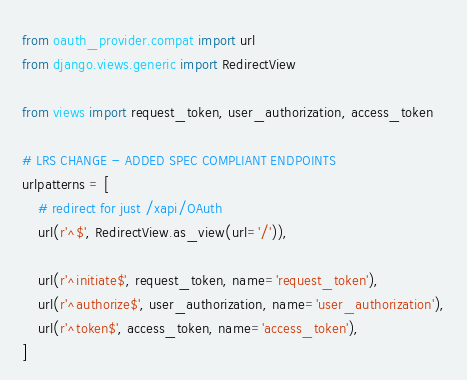<code> <loc_0><loc_0><loc_500><loc_500><_Python_>from oauth_provider.compat import url
from django.views.generic import RedirectView

from views import request_token, user_authorization, access_token

# LRS CHANGE - ADDED SPEC COMPLIANT ENDPOINTS
urlpatterns = [
    # redirect for just /xapi/OAuth
    url(r'^$', RedirectView.as_view(url='/')),

    url(r'^initiate$', request_token, name='request_token'),
    url(r'^authorize$', user_authorization, name='user_authorization'),
    url(r'^token$', access_token, name='access_token'),
]
</code> 